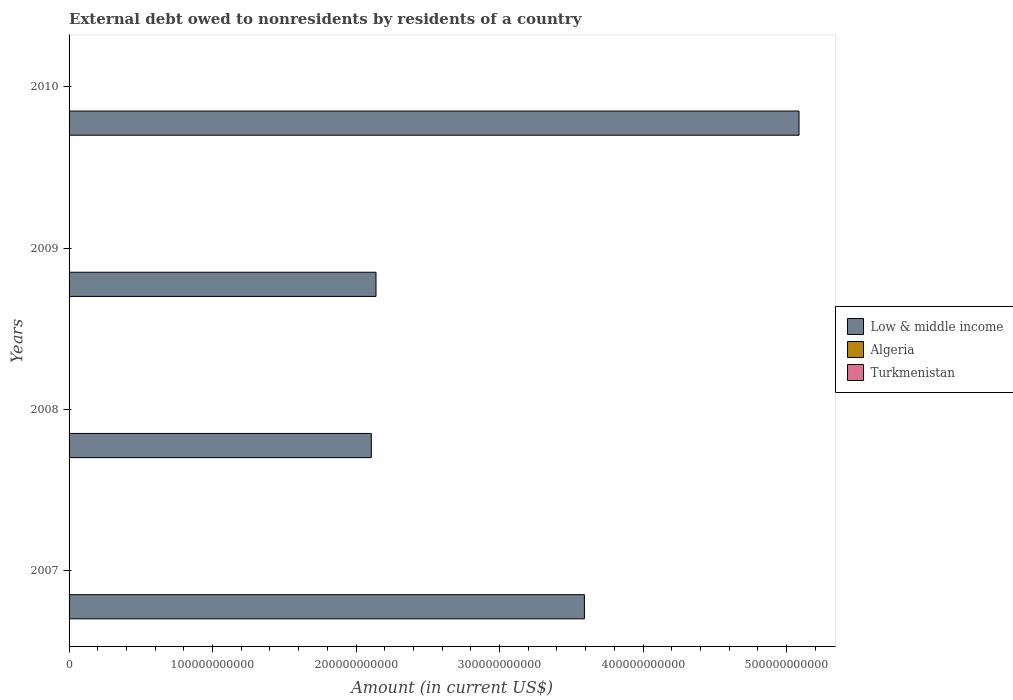Are the number of bars on each tick of the Y-axis equal?
Give a very brief answer. No. Across all years, what is the maximum external debt owed by residents in Algeria?
Offer a terse response. 1.71e+08. In which year was the external debt owed by residents in Algeria maximum?
Your response must be concise. 2008. What is the total external debt owed by residents in Low & middle income in the graph?
Keep it short and to the point. 1.29e+12. What is the difference between the external debt owed by residents in Low & middle income in 2008 and that in 2010?
Provide a short and direct response. -2.98e+11. What is the difference between the external debt owed by residents in Algeria in 2010 and the external debt owed by residents in Turkmenistan in 2007?
Your answer should be compact. 0. What is the average external debt owed by residents in Algeria per year?
Offer a very short reply. 4.28e+07. In how many years, is the external debt owed by residents in Low & middle income greater than 500000000000 US$?
Provide a succinct answer. 1. What is the difference between the highest and the second highest external debt owed by residents in Low & middle income?
Your answer should be compact. 1.50e+11. How many years are there in the graph?
Your answer should be compact. 4. What is the difference between two consecutive major ticks on the X-axis?
Keep it short and to the point. 1.00e+11. Are the values on the major ticks of X-axis written in scientific E-notation?
Provide a succinct answer. No. Where does the legend appear in the graph?
Your response must be concise. Center right. How many legend labels are there?
Offer a very short reply. 3. How are the legend labels stacked?
Keep it short and to the point. Vertical. What is the title of the graph?
Your response must be concise. External debt owed to nonresidents by residents of a country. Does "Cyprus" appear as one of the legend labels in the graph?
Offer a terse response. No. What is the label or title of the X-axis?
Your response must be concise. Amount (in current US$). What is the label or title of the Y-axis?
Give a very brief answer. Years. What is the Amount (in current US$) of Low & middle income in 2007?
Provide a short and direct response. 3.59e+11. What is the Amount (in current US$) of Turkmenistan in 2007?
Provide a short and direct response. 0. What is the Amount (in current US$) in Low & middle income in 2008?
Make the answer very short. 2.11e+11. What is the Amount (in current US$) in Algeria in 2008?
Make the answer very short. 1.71e+08. What is the Amount (in current US$) in Turkmenistan in 2008?
Make the answer very short. 0. What is the Amount (in current US$) of Low & middle income in 2009?
Give a very brief answer. 2.14e+11. What is the Amount (in current US$) in Algeria in 2009?
Provide a succinct answer. 0. What is the Amount (in current US$) in Turkmenistan in 2009?
Make the answer very short. 0. What is the Amount (in current US$) in Low & middle income in 2010?
Provide a succinct answer. 5.09e+11. Across all years, what is the maximum Amount (in current US$) in Low & middle income?
Give a very brief answer. 5.09e+11. Across all years, what is the maximum Amount (in current US$) of Algeria?
Keep it short and to the point. 1.71e+08. Across all years, what is the minimum Amount (in current US$) of Low & middle income?
Your answer should be compact. 2.11e+11. Across all years, what is the minimum Amount (in current US$) of Algeria?
Your answer should be compact. 0. What is the total Amount (in current US$) in Low & middle income in the graph?
Provide a succinct answer. 1.29e+12. What is the total Amount (in current US$) in Algeria in the graph?
Your response must be concise. 1.71e+08. What is the difference between the Amount (in current US$) of Low & middle income in 2007 and that in 2008?
Your response must be concise. 1.49e+11. What is the difference between the Amount (in current US$) in Low & middle income in 2007 and that in 2009?
Offer a terse response. 1.45e+11. What is the difference between the Amount (in current US$) of Low & middle income in 2007 and that in 2010?
Offer a very short reply. -1.50e+11. What is the difference between the Amount (in current US$) of Low & middle income in 2008 and that in 2009?
Provide a short and direct response. -3.27e+09. What is the difference between the Amount (in current US$) of Low & middle income in 2008 and that in 2010?
Keep it short and to the point. -2.98e+11. What is the difference between the Amount (in current US$) in Low & middle income in 2009 and that in 2010?
Offer a terse response. -2.95e+11. What is the difference between the Amount (in current US$) of Low & middle income in 2007 and the Amount (in current US$) of Algeria in 2008?
Your answer should be compact. 3.59e+11. What is the average Amount (in current US$) of Low & middle income per year?
Your response must be concise. 3.23e+11. What is the average Amount (in current US$) in Algeria per year?
Make the answer very short. 4.28e+07. In the year 2008, what is the difference between the Amount (in current US$) in Low & middle income and Amount (in current US$) in Algeria?
Your answer should be compact. 2.10e+11. What is the ratio of the Amount (in current US$) in Low & middle income in 2007 to that in 2008?
Give a very brief answer. 1.71. What is the ratio of the Amount (in current US$) in Low & middle income in 2007 to that in 2009?
Provide a short and direct response. 1.68. What is the ratio of the Amount (in current US$) of Low & middle income in 2007 to that in 2010?
Your answer should be compact. 0.71. What is the ratio of the Amount (in current US$) in Low & middle income in 2008 to that in 2009?
Your answer should be compact. 0.98. What is the ratio of the Amount (in current US$) in Low & middle income in 2008 to that in 2010?
Provide a succinct answer. 0.41. What is the ratio of the Amount (in current US$) of Low & middle income in 2009 to that in 2010?
Your answer should be very brief. 0.42. What is the difference between the highest and the second highest Amount (in current US$) in Low & middle income?
Provide a short and direct response. 1.50e+11. What is the difference between the highest and the lowest Amount (in current US$) of Low & middle income?
Your answer should be very brief. 2.98e+11. What is the difference between the highest and the lowest Amount (in current US$) in Algeria?
Offer a terse response. 1.71e+08. 